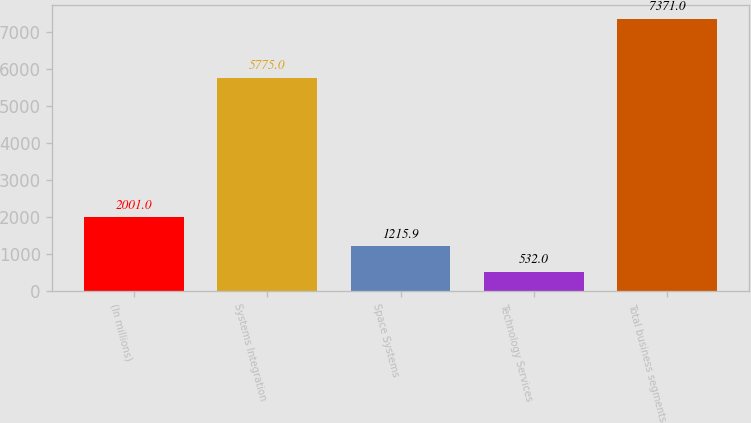Convert chart. <chart><loc_0><loc_0><loc_500><loc_500><bar_chart><fcel>(In millions)<fcel>Systems Integration<fcel>Space Systems<fcel>Technology Services<fcel>Total business segments<nl><fcel>2001<fcel>5775<fcel>1215.9<fcel>532<fcel>7371<nl></chart> 